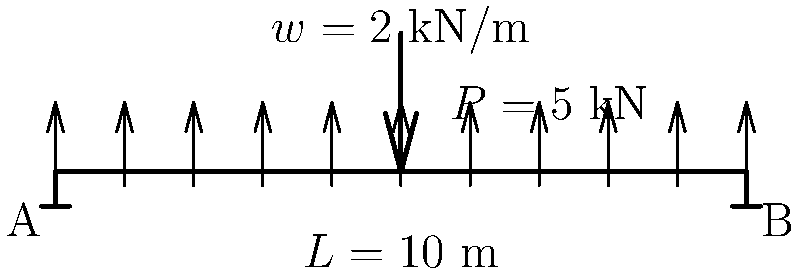As a manufacturing plant manager overseeing equipment installation, you need to ensure the structural integrity of support beams. Consider a simply supported beam of length $L = 10$ m subjected to a uniformly distributed load of $w = 2$ kN/m along its entire length and a point load of $P = 5$ kN at the center. Calculate the maximum bending moment in the beam. To solve this problem, we'll follow these steps:

1) First, calculate the reactions at the supports:
   Due to symmetry, $R_A = R_B = \frac{1}{2}(wL + P)$
   $R_A = R_B = \frac{1}{2}(2 \cdot 10 + 5) = 12.5$ kN

2) The maximum bending moment will occur at the center of the beam where the point load is applied. We need to consider both the distributed load and the point load:

   a) Moment due to distributed load:
      $M_{dist} = \frac{wL^2}{8} = \frac{2 \cdot 10^2}{8} = 25$ kN·m

   b) Moment due to point load:
      $M_{point} = \frac{PL}{4} = \frac{5 \cdot 10}{4} = 12.5$ kN·m

3) The total maximum bending moment is the sum of these two:
   $M_{max} = M_{dist} + M_{point} = 25 + 12.5 = 37.5$ kN·m

This calculation ensures that the beam can withstand the combined loads without failure, which is crucial for maintaining a safe and efficient manufacturing environment.
Answer: $37.5$ kN·m 